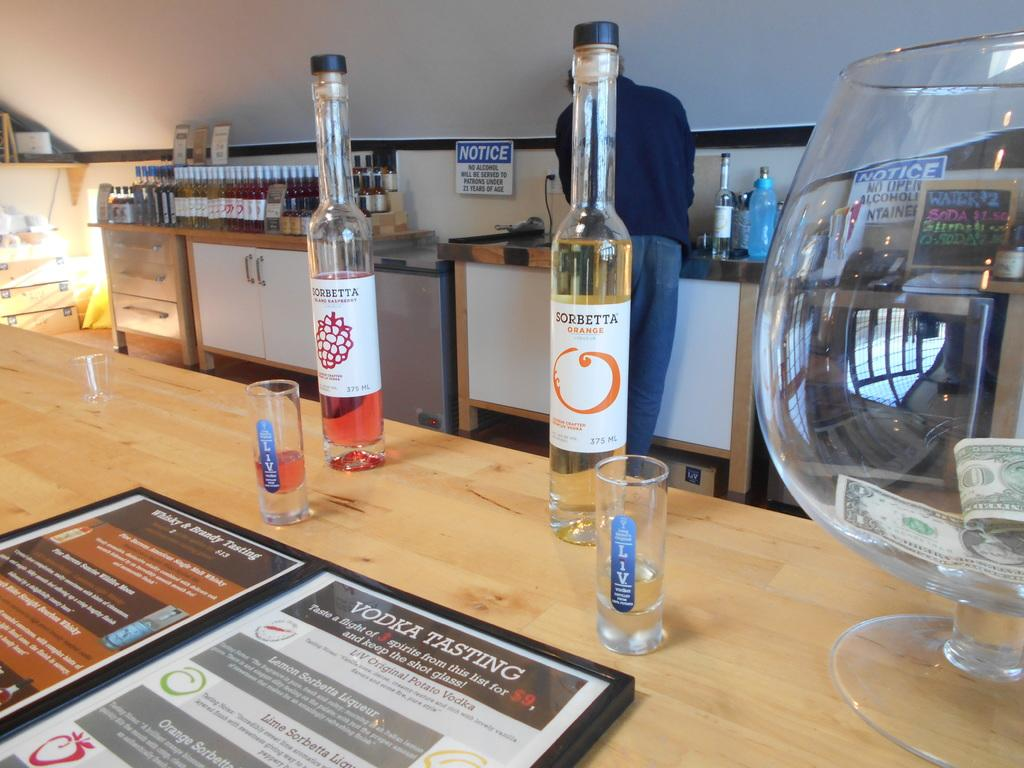What objects are present on the table in the image? There are bottles, glasses, and a menu on the table. How many types of objects are on the table? There are three types of objects on the table: bottles, glasses, and a menu. Can you describe the person in the background? The person is standing in front of a wall in the background. What is the purpose of the menu on the table? The menu is likely used for selecting items to order or consume. How many wine bottles are on the table? There are many wine bottles on the table. What type of pump can be seen in the image? There is no pump present in the image. Can you tell me how many giraffes are in the image? There are no giraffes present in the image. 